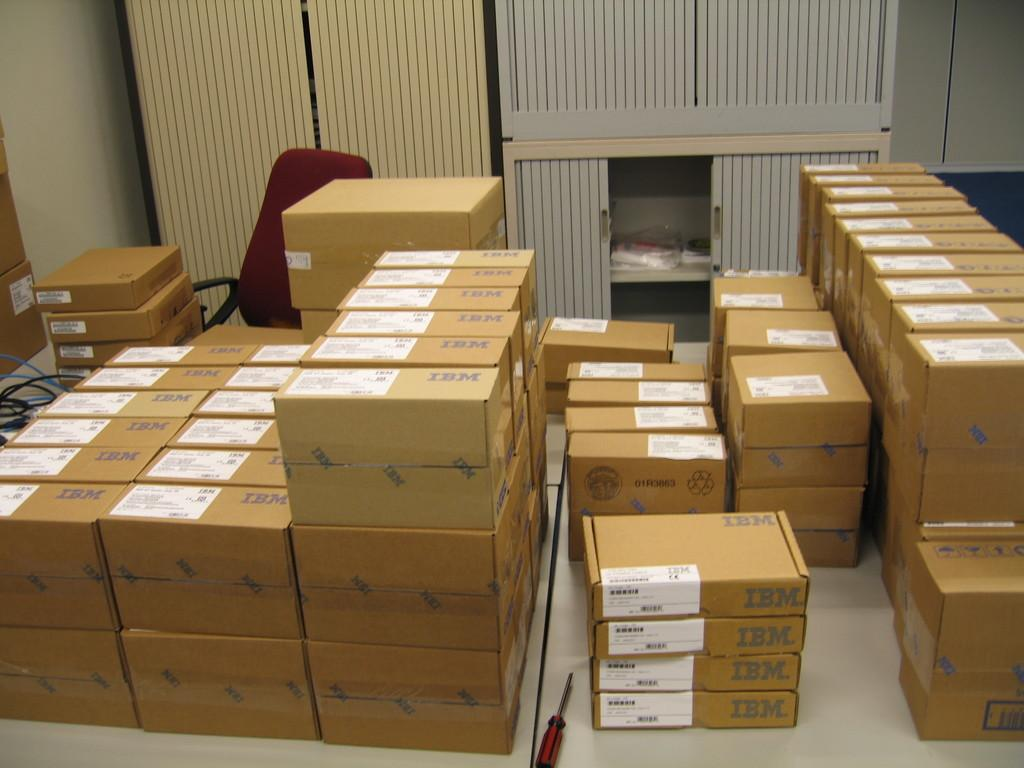<image>
Render a clear and concise summary of the photo. a bunch of boxes with the word IBM printed. 